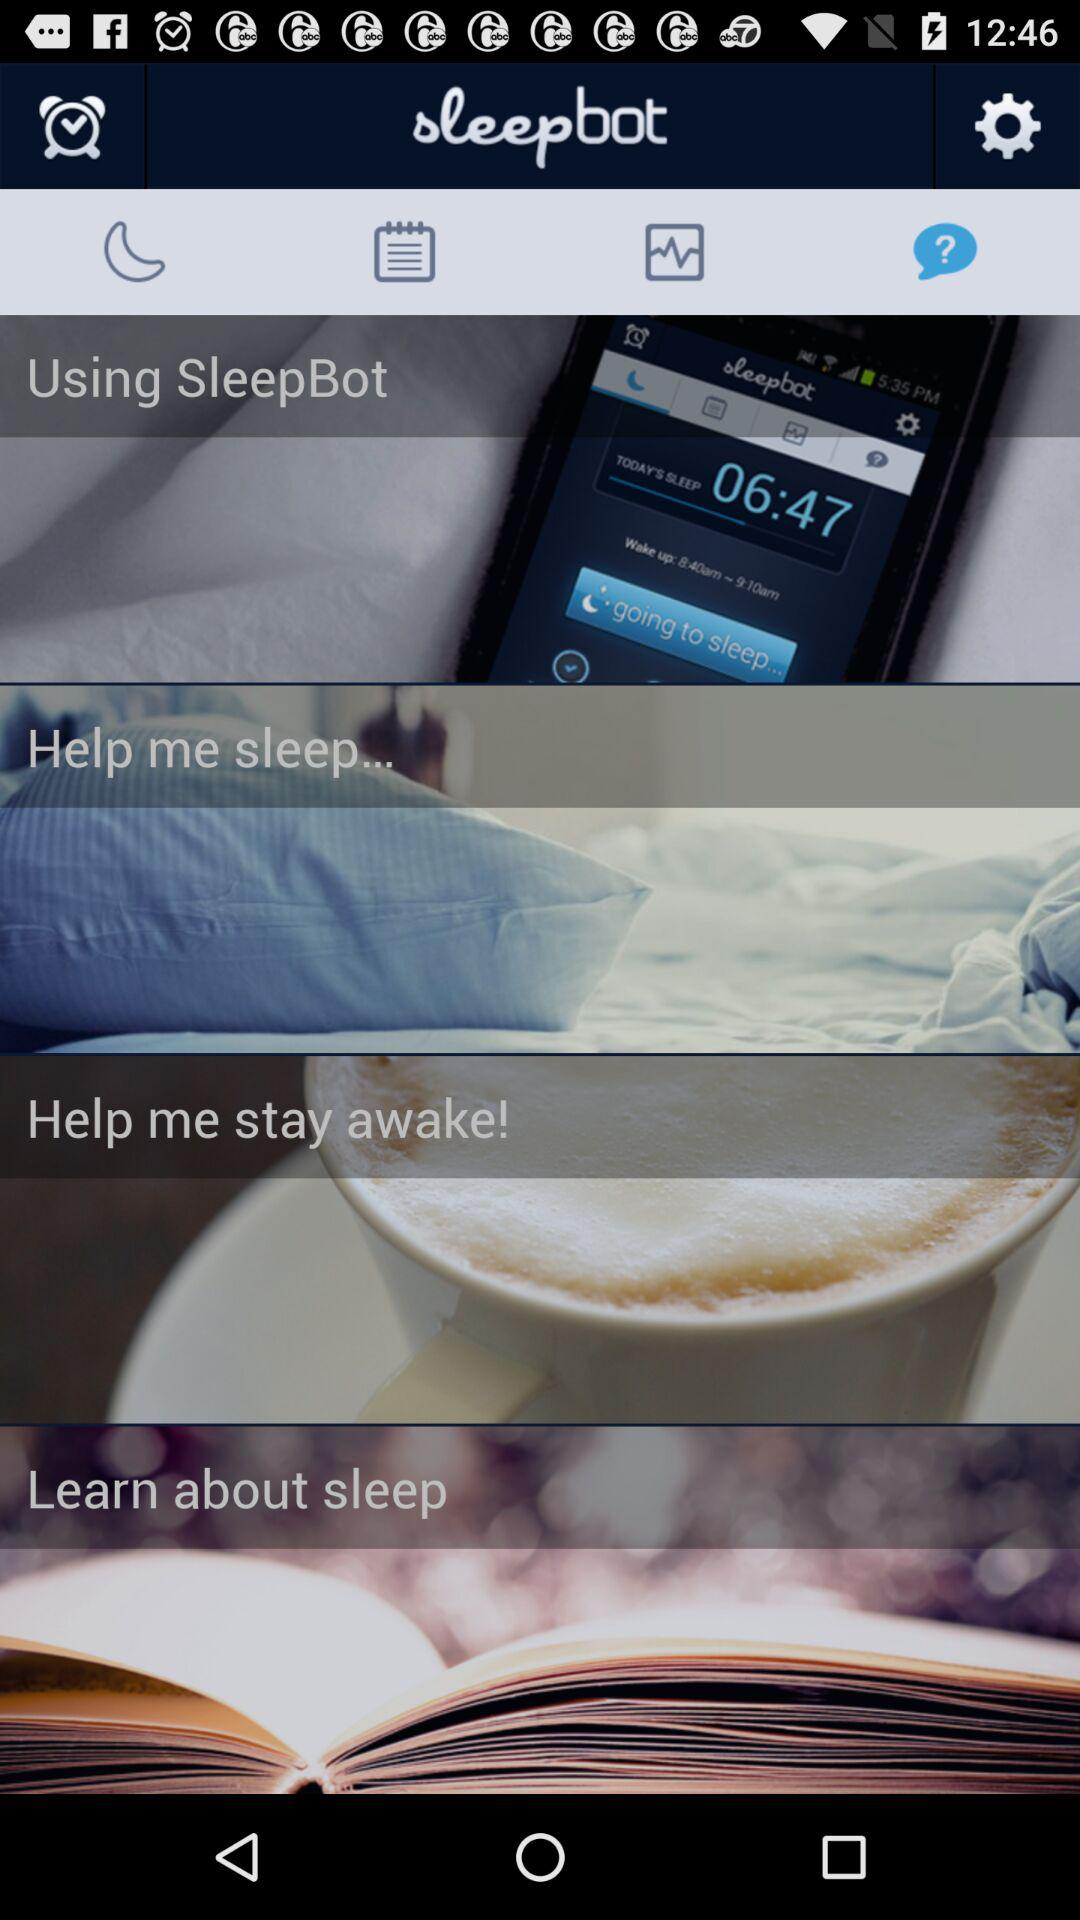What is the application name? The application name is "sleepbot". 